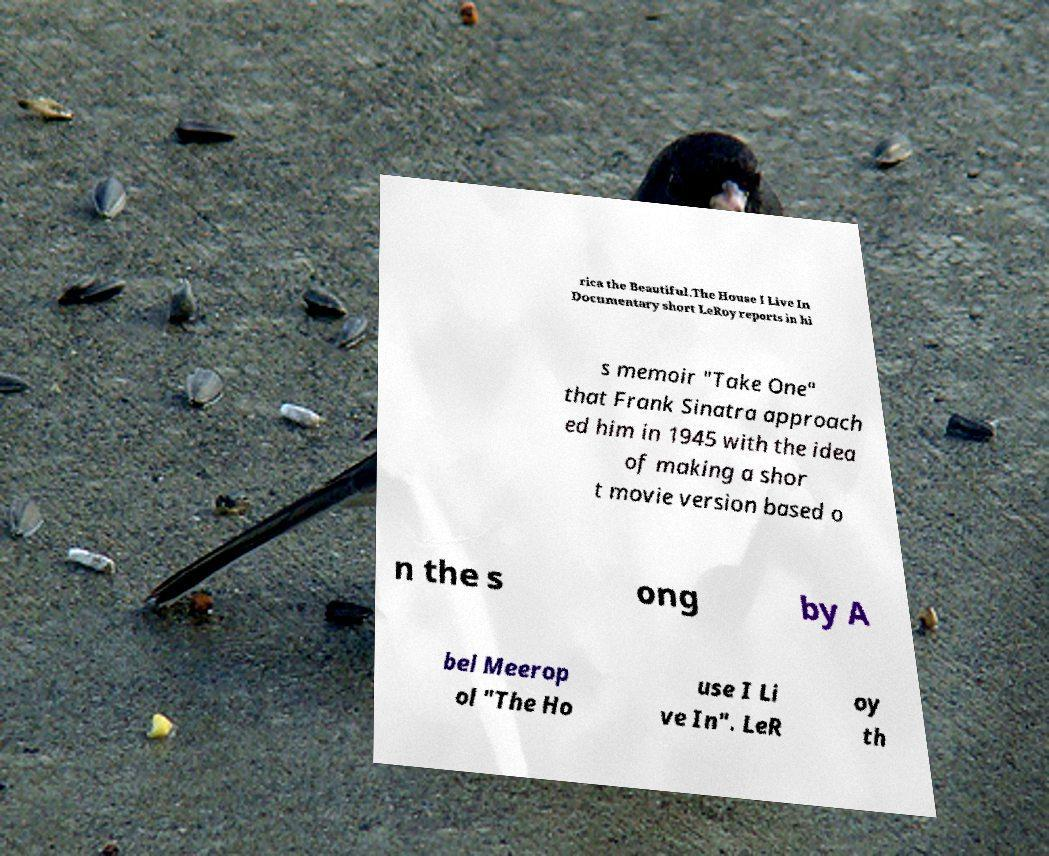Can you read and provide the text displayed in the image?This photo seems to have some interesting text. Can you extract and type it out for me? rica the Beautiful.The House I Live In Documentary short LeRoy reports in hi s memoir "Take One" that Frank Sinatra approach ed him in 1945 with the idea of making a shor t movie version based o n the s ong by A bel Meerop ol "The Ho use I Li ve In". LeR oy th 